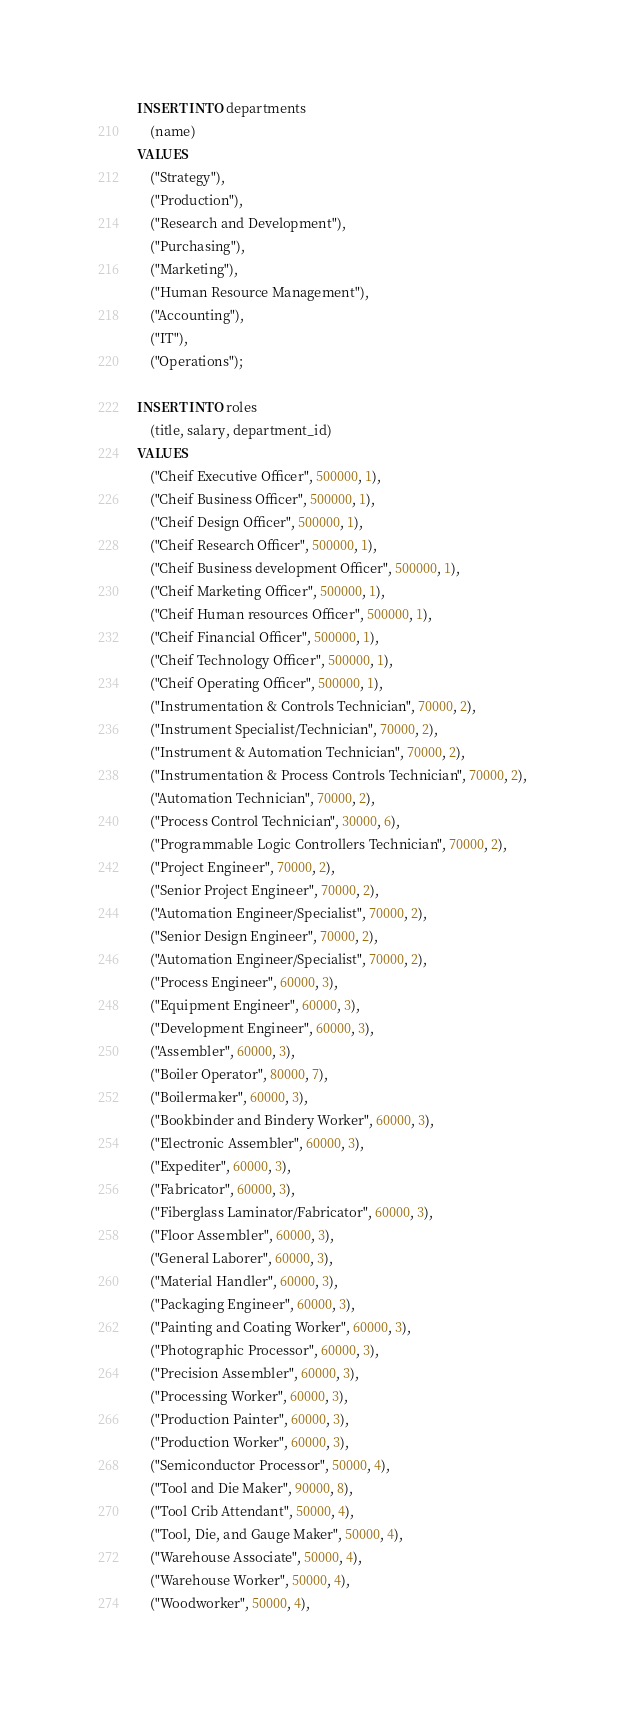Convert code to text. <code><loc_0><loc_0><loc_500><loc_500><_SQL_>INSERT INTO departments
    (name)
VALUES
    ("Strategy"),
    ("Production"),
    ("Research and Development"),
    ("Purchasing"),
    ("Marketing"),
    ("Human Resource Management"),
    ("Accounting"),
    ("IT"),
    ("Operations");

INSERT INTO roles
    (title, salary, department_id)
VALUES
    ("Cheif Executive Officer", 500000, 1),
    ("Cheif Business Officer", 500000, 1),
    ("Cheif Design Officer", 500000, 1),
    ("Cheif Research Officer", 500000, 1),
    ("Cheif Business development Officer", 500000, 1),
    ("Cheif Marketing Officer", 500000, 1),
    ("Cheif Human resources Officer", 500000, 1),
    ("Cheif Financial Officer", 500000, 1),
    ("Cheif Technology Officer", 500000, 1),
    ("Cheif Operating Officer", 500000, 1),
    ("Instrumentation & Controls Technician", 70000, 2),
    ("Instrument Specialist/Technician", 70000, 2),
    ("Instrument & Automation Technician", 70000, 2),
    ("Instrumentation & Process Controls Technician", 70000, 2),
    ("Automation Technician", 70000, 2),
    ("Process Control Technician", 30000, 6),
    ("Programmable Logic Controllers Technician", 70000, 2),
    ("Project Engineer", 70000, 2),
    ("Senior Project Engineer", 70000, 2),
    ("Automation Engineer/Specialist", 70000, 2),
    ("Senior Design Engineer", 70000, 2),
    ("Automation Engineer/Specialist", 70000, 2),
    ("Process Engineer", 60000, 3),
    ("Equipment Engineer", 60000, 3),
    ("Development Engineer", 60000, 3),
    ("Assembler", 60000, 3),
    ("Boiler Operator", 80000, 7),
    ("Boilermaker", 60000, 3),
    ("Bookbinder and Bindery Worker", 60000, 3),
    ("Electronic Assembler", 60000, 3),
    ("Expediter", 60000, 3),
    ("Fabricator", 60000, 3),
    ("Fiberglass Laminator/Fabricator", 60000, 3),
    ("Floor Assembler", 60000, 3),
    ("General Laborer", 60000, 3),
    ("Material Handler", 60000, 3),
    ("Packaging Engineer", 60000, 3),
    ("Painting and Coating Worker", 60000, 3),
    ("Photographic Processor", 60000, 3),
    ("Precision Assembler", 60000, 3),
    ("Processing Worker", 60000, 3),
    ("Production Painter", 60000, 3),
    ("Production Worker", 60000, 3),
    ("Semiconductor Processor", 50000, 4),
    ("Tool and Die Maker", 90000, 8),
    ("Tool Crib Attendant", 50000, 4),
    ("Tool, Die, and Gauge Maker", 50000, 4),
    ("Warehouse Associate", 50000, 4),
    ("Warehouse Worker", 50000, 4),
    ("Woodworker", 50000, 4),</code> 